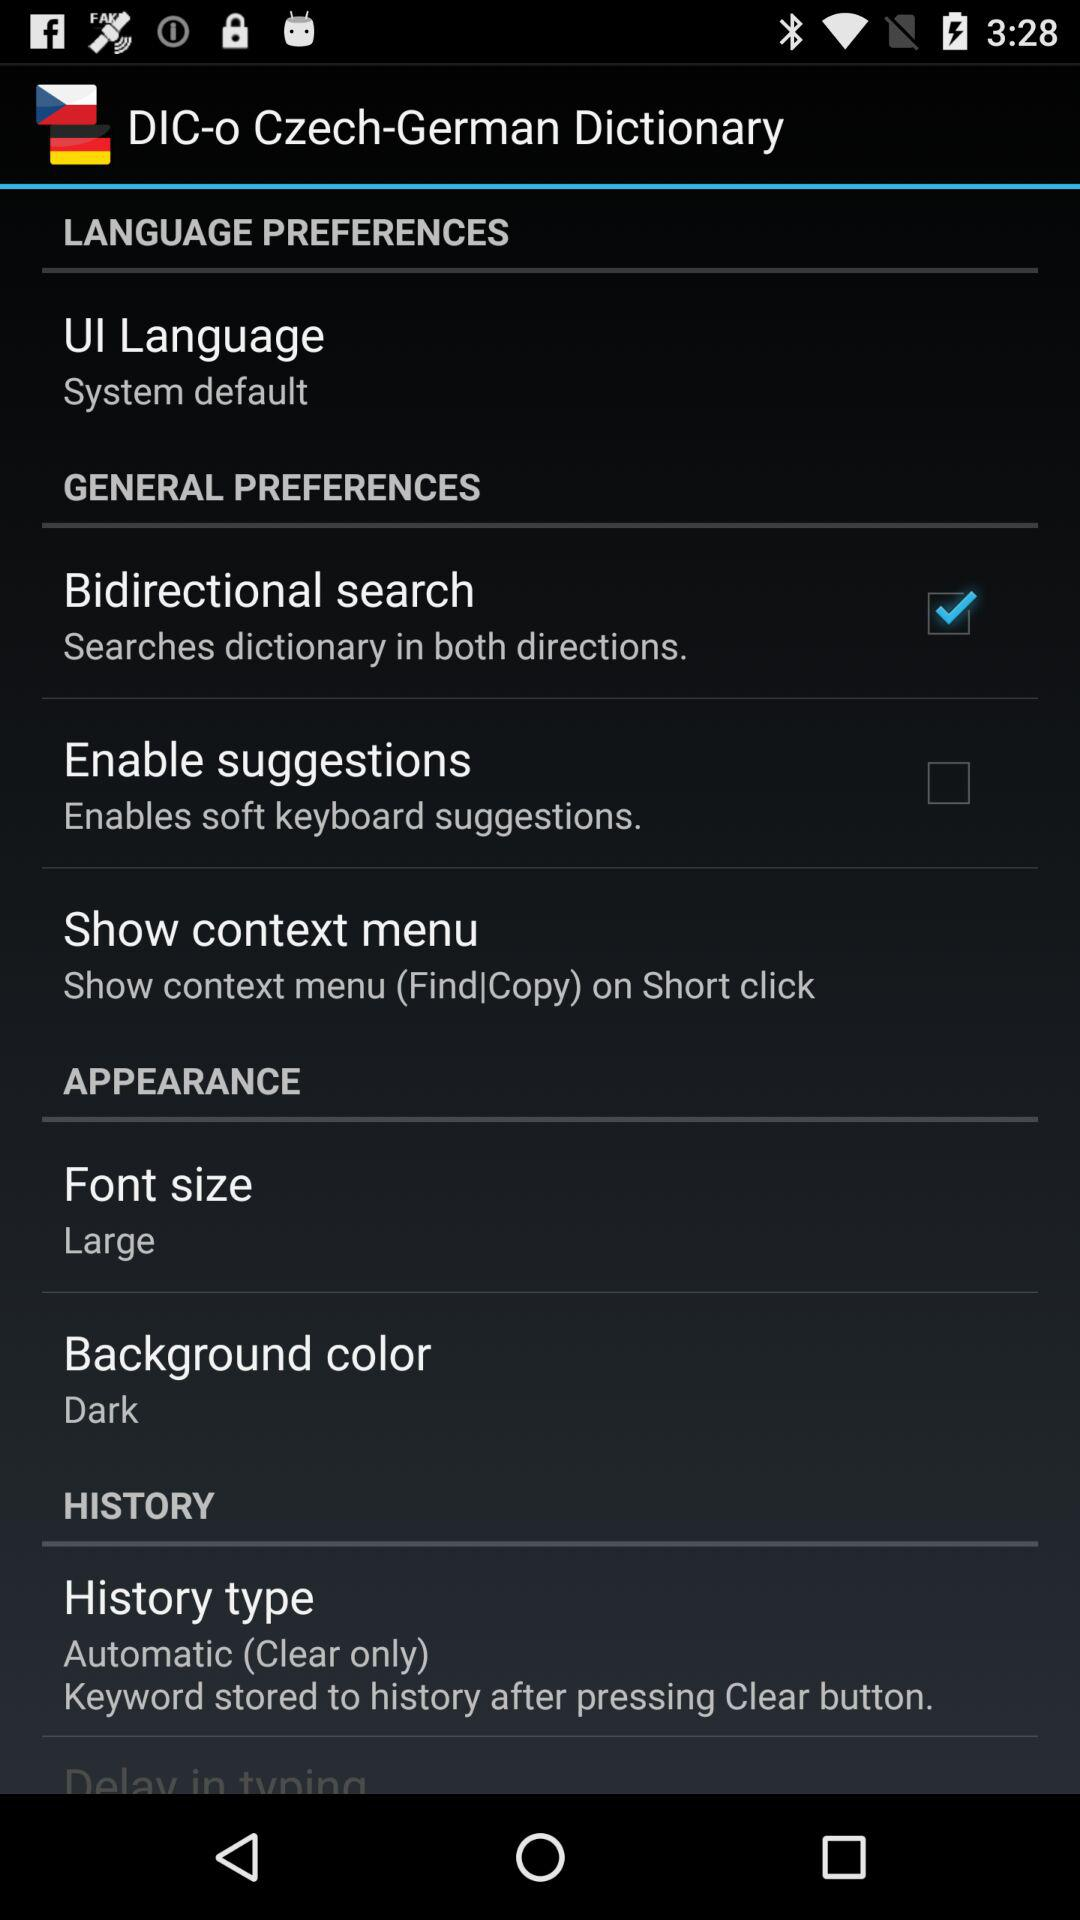What font size is selected? The selected font size is "Large". 